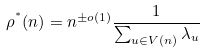Convert formula to latex. <formula><loc_0><loc_0><loc_500><loc_500>\rho ^ { ^ { * } } ( n ) = n ^ { \pm o ( 1 ) } \frac { 1 } { \sum _ { u \in V ( n ) } \lambda _ { u } }</formula> 